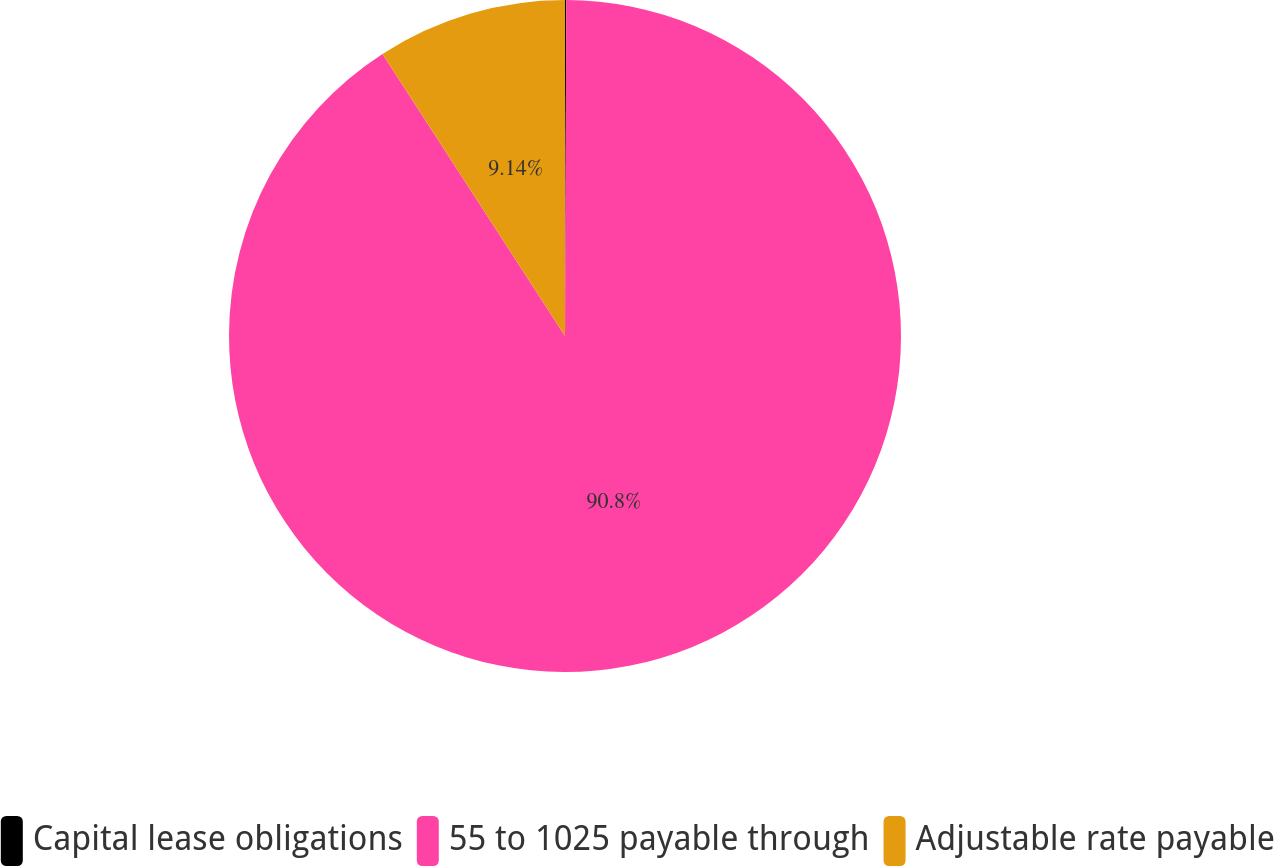Convert chart to OTSL. <chart><loc_0><loc_0><loc_500><loc_500><pie_chart><fcel>Capital lease obligations<fcel>55 to 1025 payable through<fcel>Adjustable rate payable<nl><fcel>0.06%<fcel>90.8%<fcel>9.14%<nl></chart> 